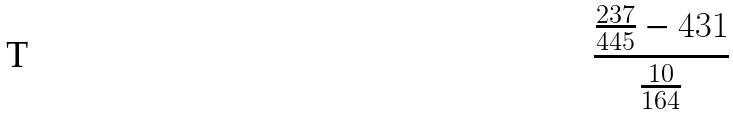Convert formula to latex. <formula><loc_0><loc_0><loc_500><loc_500>\frac { \frac { 2 3 7 } { 4 4 5 } - 4 3 1 } { \frac { 1 0 } { 1 6 4 } }</formula> 